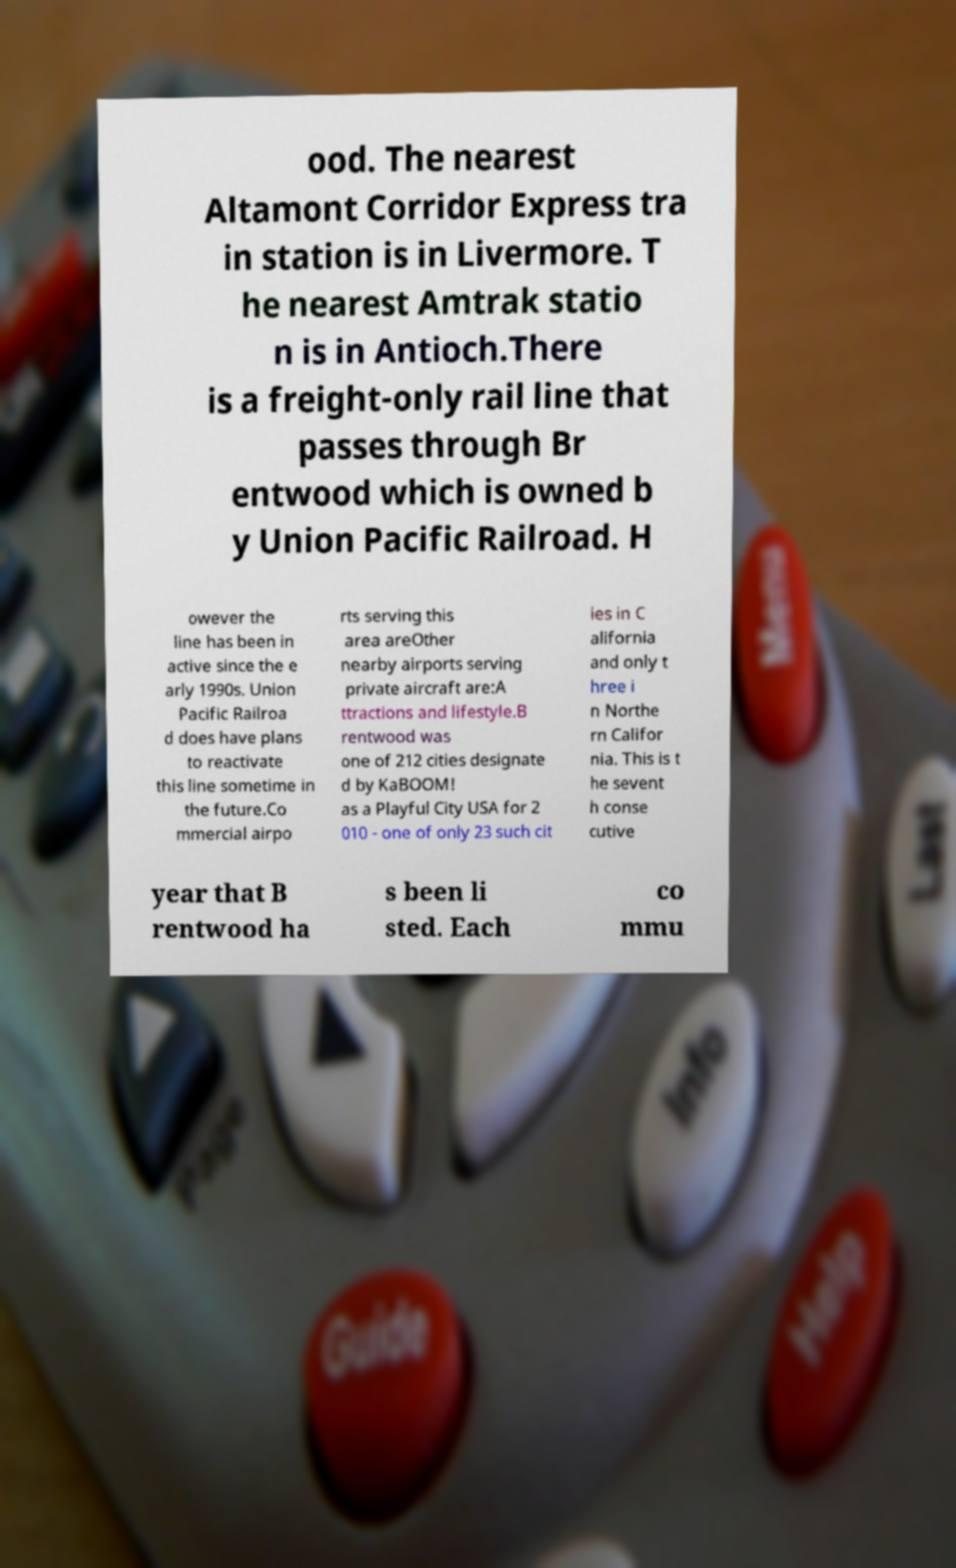There's text embedded in this image that I need extracted. Can you transcribe it verbatim? ood. The nearest Altamont Corridor Express tra in station is in Livermore. T he nearest Amtrak statio n is in Antioch.There is a freight-only rail line that passes through Br entwood which is owned b y Union Pacific Railroad. H owever the line has been in active since the e arly 1990s. Union Pacific Railroa d does have plans to reactivate this line sometime in the future.Co mmercial airpo rts serving this area areOther nearby airports serving private aircraft are:A ttractions and lifestyle.B rentwood was one of 212 cities designate d by KaBOOM! as a Playful City USA for 2 010 - one of only 23 such cit ies in C alifornia and only t hree i n Northe rn Califor nia. This is t he sevent h conse cutive year that B rentwood ha s been li sted. Each co mmu 